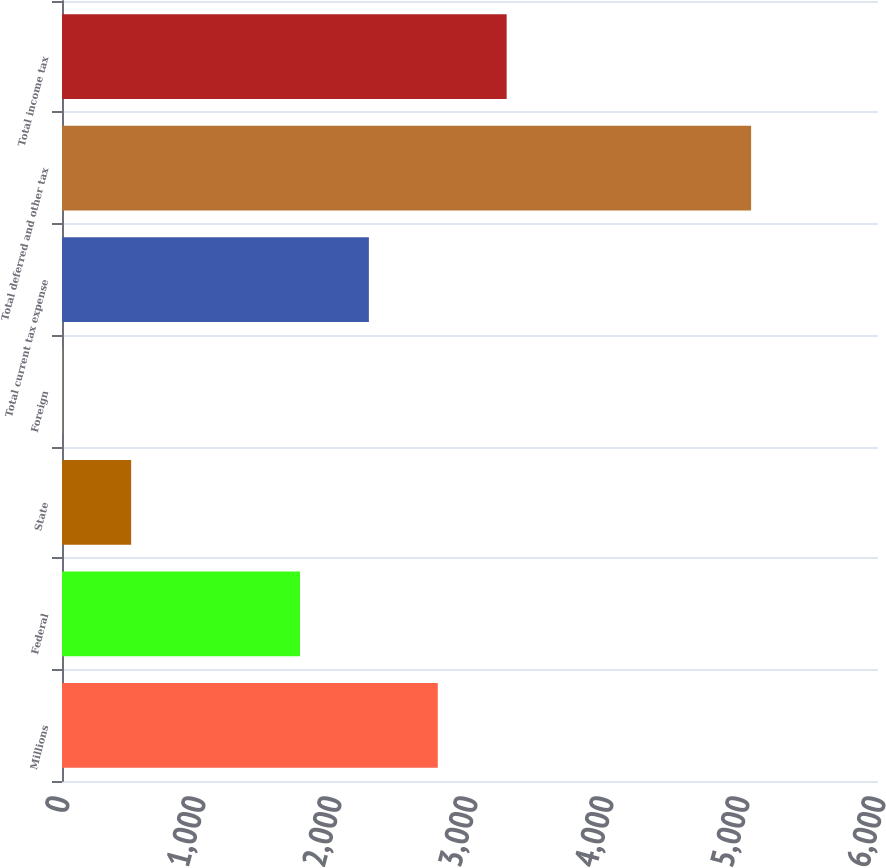Convert chart. <chart><loc_0><loc_0><loc_500><loc_500><bar_chart><fcel>Millions<fcel>Federal<fcel>State<fcel>Foreign<fcel>Total current tax expense<fcel>Total deferred and other tax<fcel>Total income tax<nl><fcel>2763<fcel>1750<fcel>508.5<fcel>2<fcel>2256.5<fcel>5067<fcel>3269.5<nl></chart> 